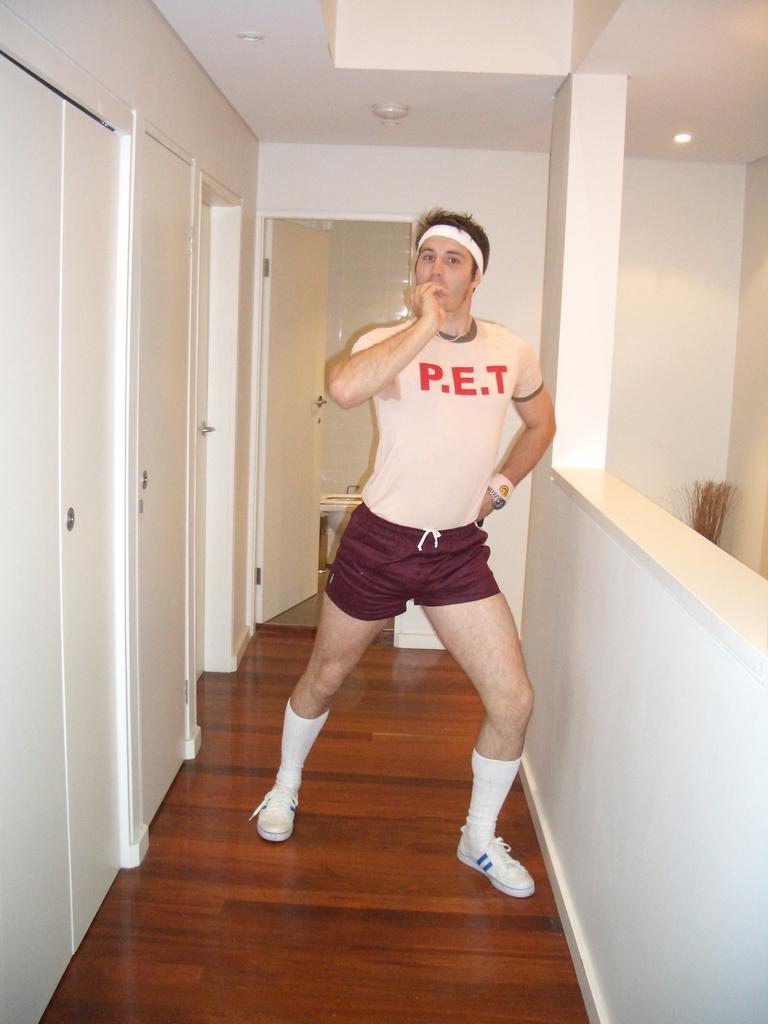<image>
Render a clear and concise summary of the photo. A man in a hallway wearing a jersey that says P.E.T. 